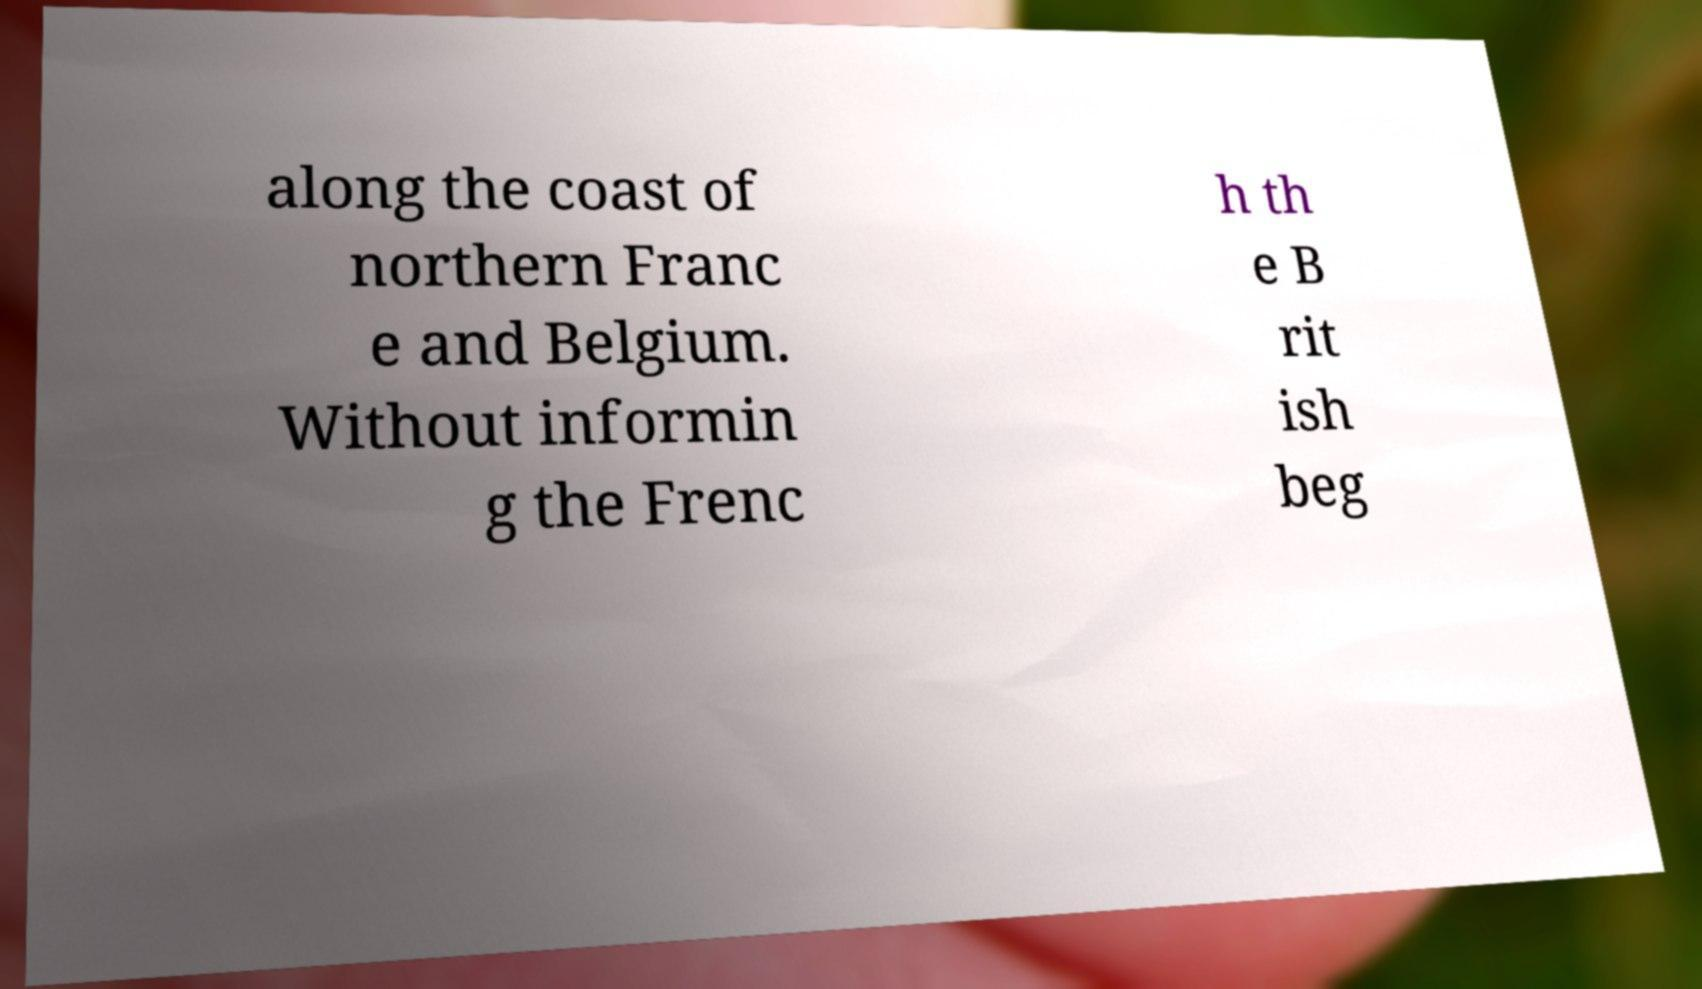For documentation purposes, I need the text within this image transcribed. Could you provide that? along the coast of northern Franc e and Belgium. Without informin g the Frenc h th e B rit ish beg 